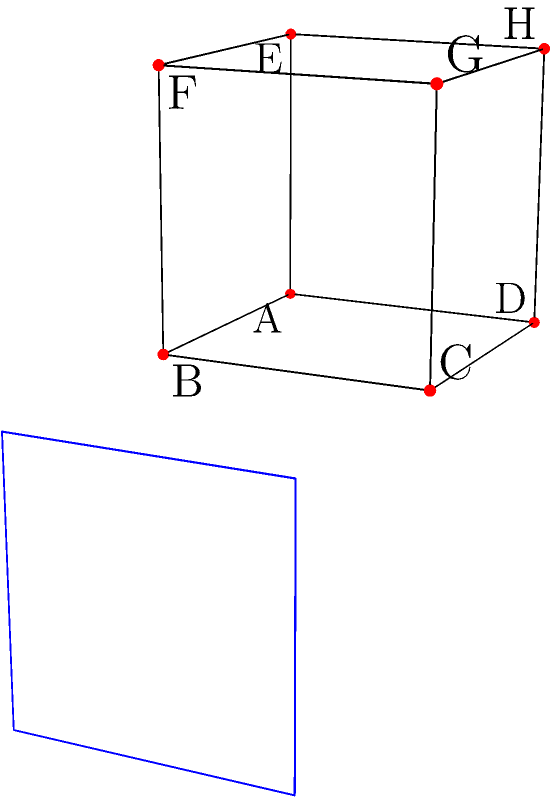In a C# application, you're working with a 3D cube where each face represents a different class. The cube is initially in the position shown on the left. If you apply a 90-degree rotation around the Y-axis (vertical axis) in a clockwise direction when viewed from above, which face of the cube (represented by its vertices) will be facing the front after the rotation? To solve this problem, let's follow these steps:

1. Understand the initial cube position:
   - Front face: ABCD
   - Right face: BCGF
   - Left face: ADHE
   - Top face: EFGH
   - Bottom face: ABFE
   - Back face: CDHG

2. Visualize the rotation:
   - A 90-degree clockwise rotation around the Y-axis means the right face will become the front face.

3. Identify the new front face:
   - The right face before rotation was BCGF.
   - After rotation, this face (BCGF) will be the new front face.

4. Check the orientation:
   - The rotation doesn't change the top-bottom orientation of the face.
   - B will be at the bottom-left, C at the bottom-right, G at the top-right, and F at the top-left of the new front face.

5. Confirm the result:
   - The new front face is indeed BCGF, with B and C at the bottom, and F and G at the top.

This rotation simulates how different classes in a C# application might be reorganized or reprioritized in the program's structure, with the most important or frequently accessed classes moving to the "front" of the conceptual cube.
Answer: BCGF 